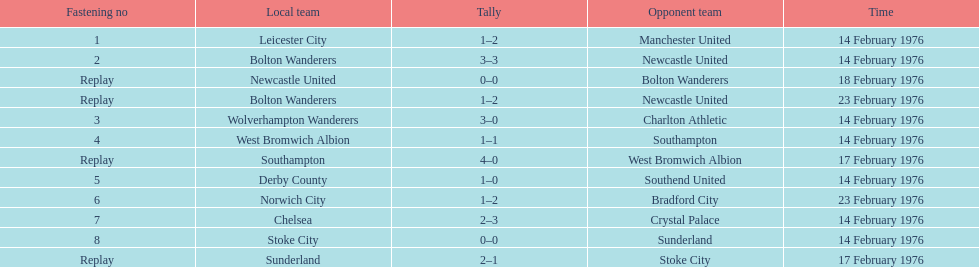Who had a better score, manchester united or wolverhampton wanderers? Wolverhampton Wanderers. 